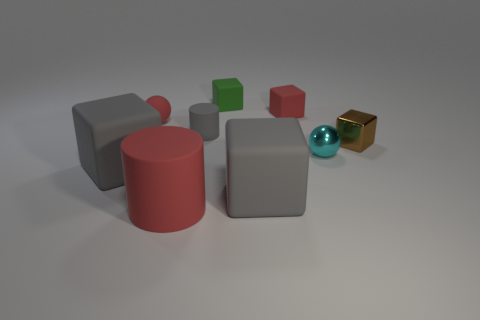Subtract all small green blocks. How many blocks are left? 4 Subtract all green cylinders. How many gray blocks are left? 2 Subtract all red balls. How many balls are left? 1 Subtract 2 cubes. How many cubes are left? 3 Subtract all gray blocks. Subtract all red spheres. How many blocks are left? 3 Add 1 small yellow shiny cylinders. How many objects exist? 10 Subtract all cylinders. How many objects are left? 7 Add 6 brown balls. How many brown balls exist? 6 Subtract 1 red blocks. How many objects are left? 8 Subtract all blue rubber objects. Subtract all brown blocks. How many objects are left? 8 